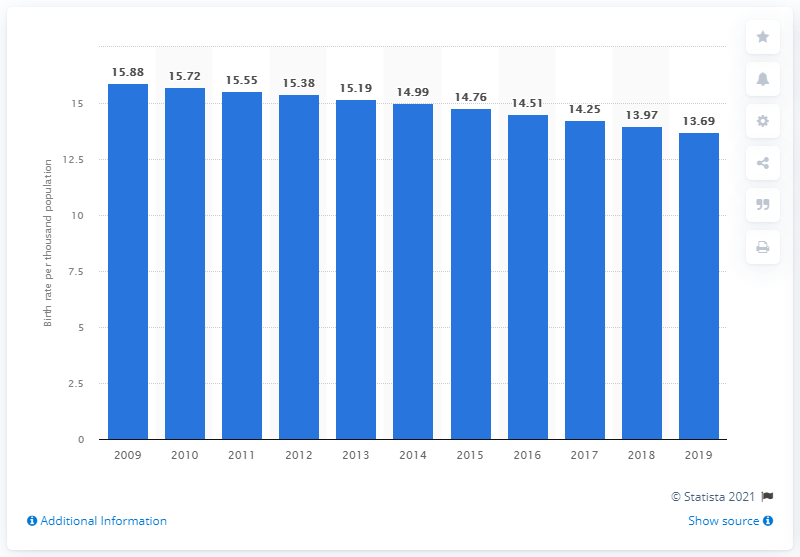Point out several critical features in this image. In 2019, the crude birth rate in Costa Rica was 13.69. 